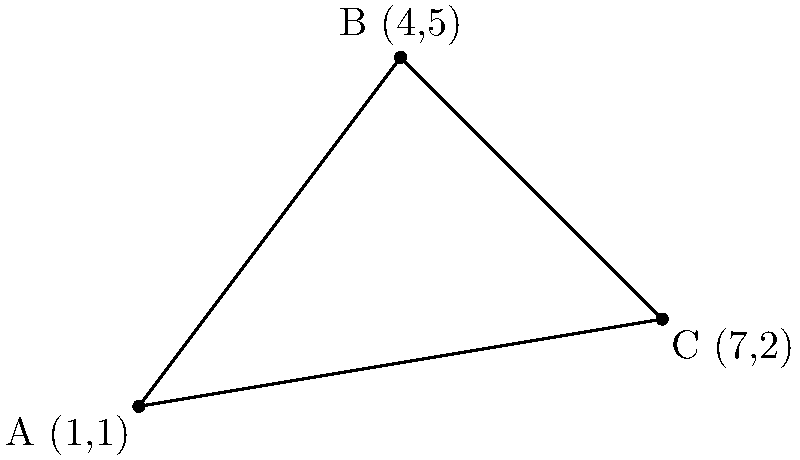In the coordinate system shown above, points A(1,1), B(4,5), and C(7,2) form a triangle. Calculate the area of this triangle using the coordinate geometry method. Round your answer to two decimal places. To calculate the area of a triangle given three points, we can use the formula:

$$\text{Area} = \frac{1}{2}|x_1(y_2 - y_3) + x_2(y_3 - y_1) + x_3(y_1 - y_2)|$$

Where $(x_1, y_1)$, $(x_2, y_2)$, and $(x_3, y_3)$ are the coordinates of the three points.

Let's substitute the given coordinates:
A(1,1), B(4,5), C(7,2)

Step 1: Apply the formula
$$\text{Area} = \frac{1}{2}|1(5 - 2) + 4(2 - 1) + 7(1 - 5)|$$

Step 2: Simplify
$$\text{Area} = \frac{1}{2}|1(3) + 4(1) + 7(-4)|$$
$$\text{Area} = \frac{1}{2}|3 + 4 - 28|$$

Step 3: Calculate
$$\text{Area} = \frac{1}{2}|-21|$$
$$\text{Area} = \frac{1}{2}(21)$$
$$\text{Area} = 10.5$$

Step 4: Round to two decimal places
$$\text{Area} \approx 10.50$$

Therefore, the area of the triangle is approximately 10.50 square units.
Answer: 10.50 square units 